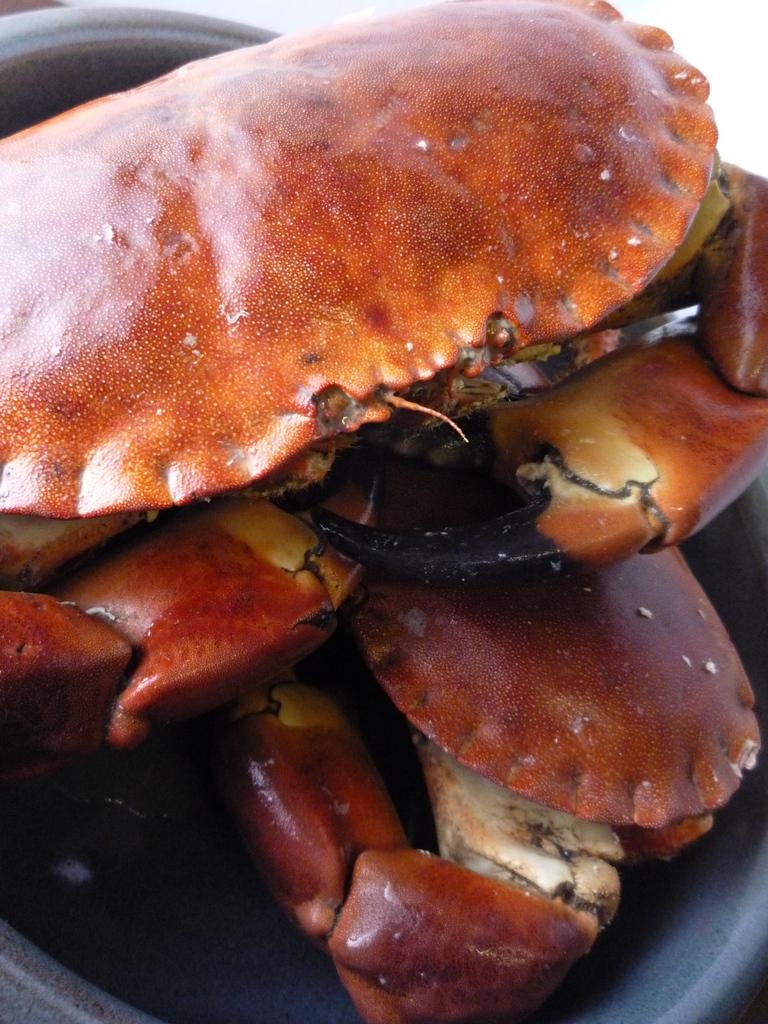What type of animal is in the image? The facts do not specify the type of animal, but it has brown, black, orange, and white colors. Can you describe the color pattern of the animal? The animal has brown, black, orange, and white colors. What is the background or surface the animal is on? The animal is on a black surface. How many friends does the animal have on its voyage in the image? There is no indication of a voyage or friends in the image; it only shows an animal on a black surface. 